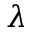<formula> <loc_0><loc_0><loc_500><loc_500>\lambda</formula> 